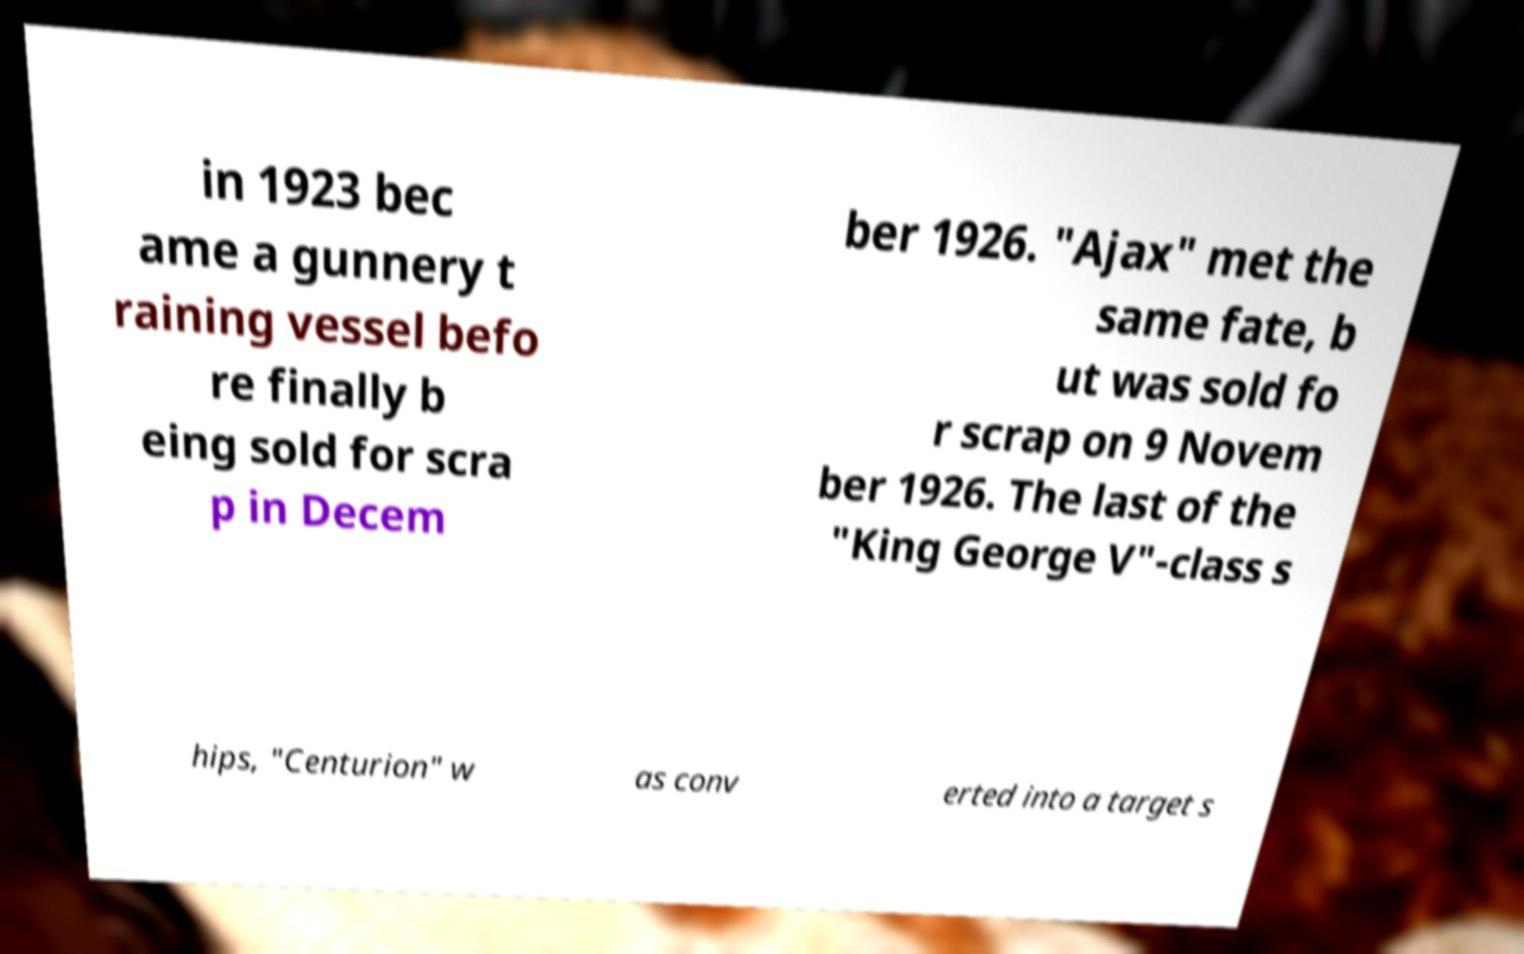Please read and relay the text visible in this image. What does it say? in 1923 bec ame a gunnery t raining vessel befo re finally b eing sold for scra p in Decem ber 1926. "Ajax" met the same fate, b ut was sold fo r scrap on 9 Novem ber 1926. The last of the "King George V"-class s hips, "Centurion" w as conv erted into a target s 